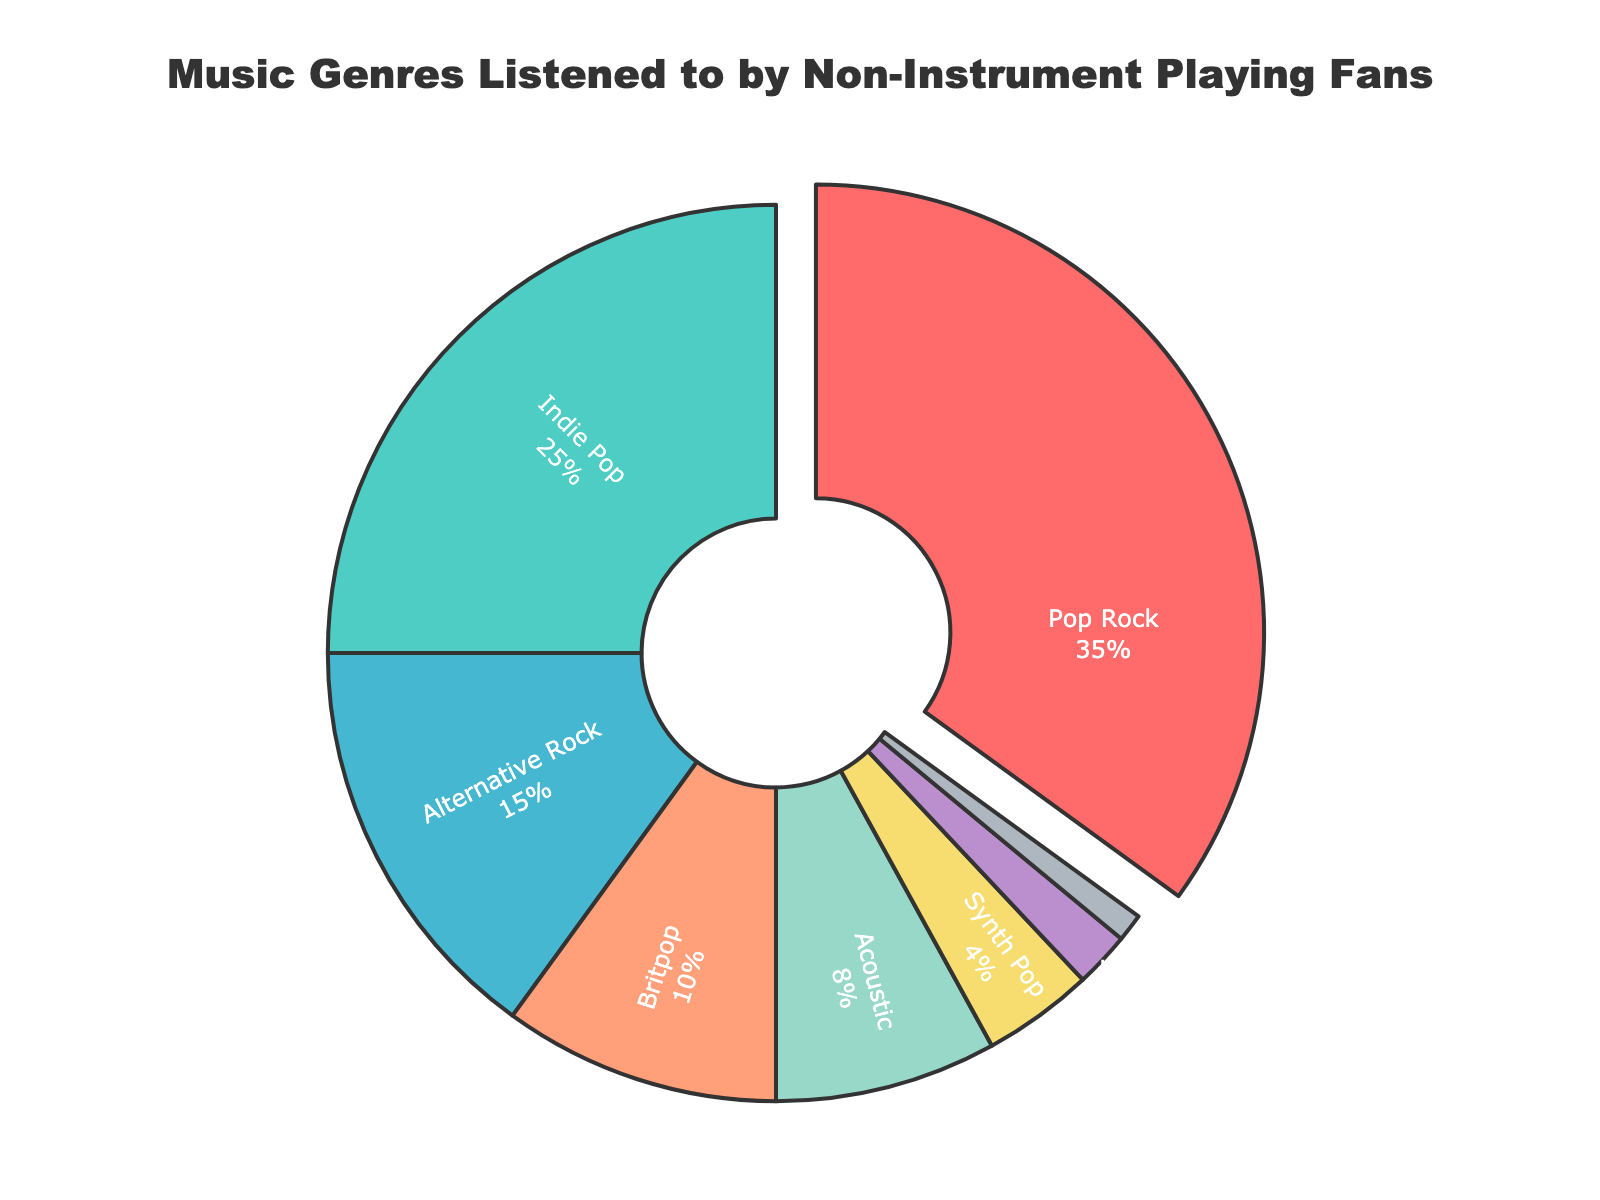what is the title of the figure? The title is usually visually distinct, often positioned at the top-center of the figure. According to the given plot generation code, the title should be prominently displayed.
Answer: Music Genres Listened to by Non-Instrument Playing Fans Which genre has the highest percentage? The figure shows multiple genres with percentages. By examining the chart, you can identify the genre with the highest percentage.
Answer: Pop Rock What percentage of fans listen to Indie Pop? Inspect the chart and locate the Indie Pop segment, which should list its percentage.
Answer: 25% What is the combined percentage of Britpop and Acoustic fans? Add the percentages of Britpop and Acoustic from the chart: Britpop (10%) + Acoustic (8%) = 18%.
Answer: 18% How does the percentage of Pop Rock fans compare to Alternative Rock fans? Look at the percentages of Pop Rock (35%) and Alternative Rock (15%) directly from the chart. Pop Rock has a higher percentage.
Answer: Pop Rock > Alternative Rock Which genre has the smallest percentage? Find the segment with the smallest percentage. According to the data, it should be the smallest wedge in the plot.
Answer: Power Pop What is the difference in percentage between Synth Pop and Folk Rock? Subtract the percentage of Folk Rock (2%) from Synth Pop (4%): 4% - 2% = 2%.
Answer: 2% What color is used for the Britpop segment? Examine the color coding in the pie chart and identify the color used for Britpop. According to the color setup, Britpop is represented by a specific color.
Answer: Light Salmon (approximation based on color codes) How many genres are listed in the figure? Count the number of different genres labeled in the pie chart. Each segment typically represents one genre.
Answer: 8 